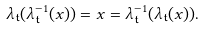<formula> <loc_0><loc_0><loc_500><loc_500>\lambda _ { \mathfrak { t } } ( \lambda ^ { - 1 } _ { \mathfrak { t } } ( x ) ) = x = \lambda ^ { - 1 } _ { \mathfrak { t } } ( \lambda _ { \mathfrak { t } } ( x ) ) .</formula> 